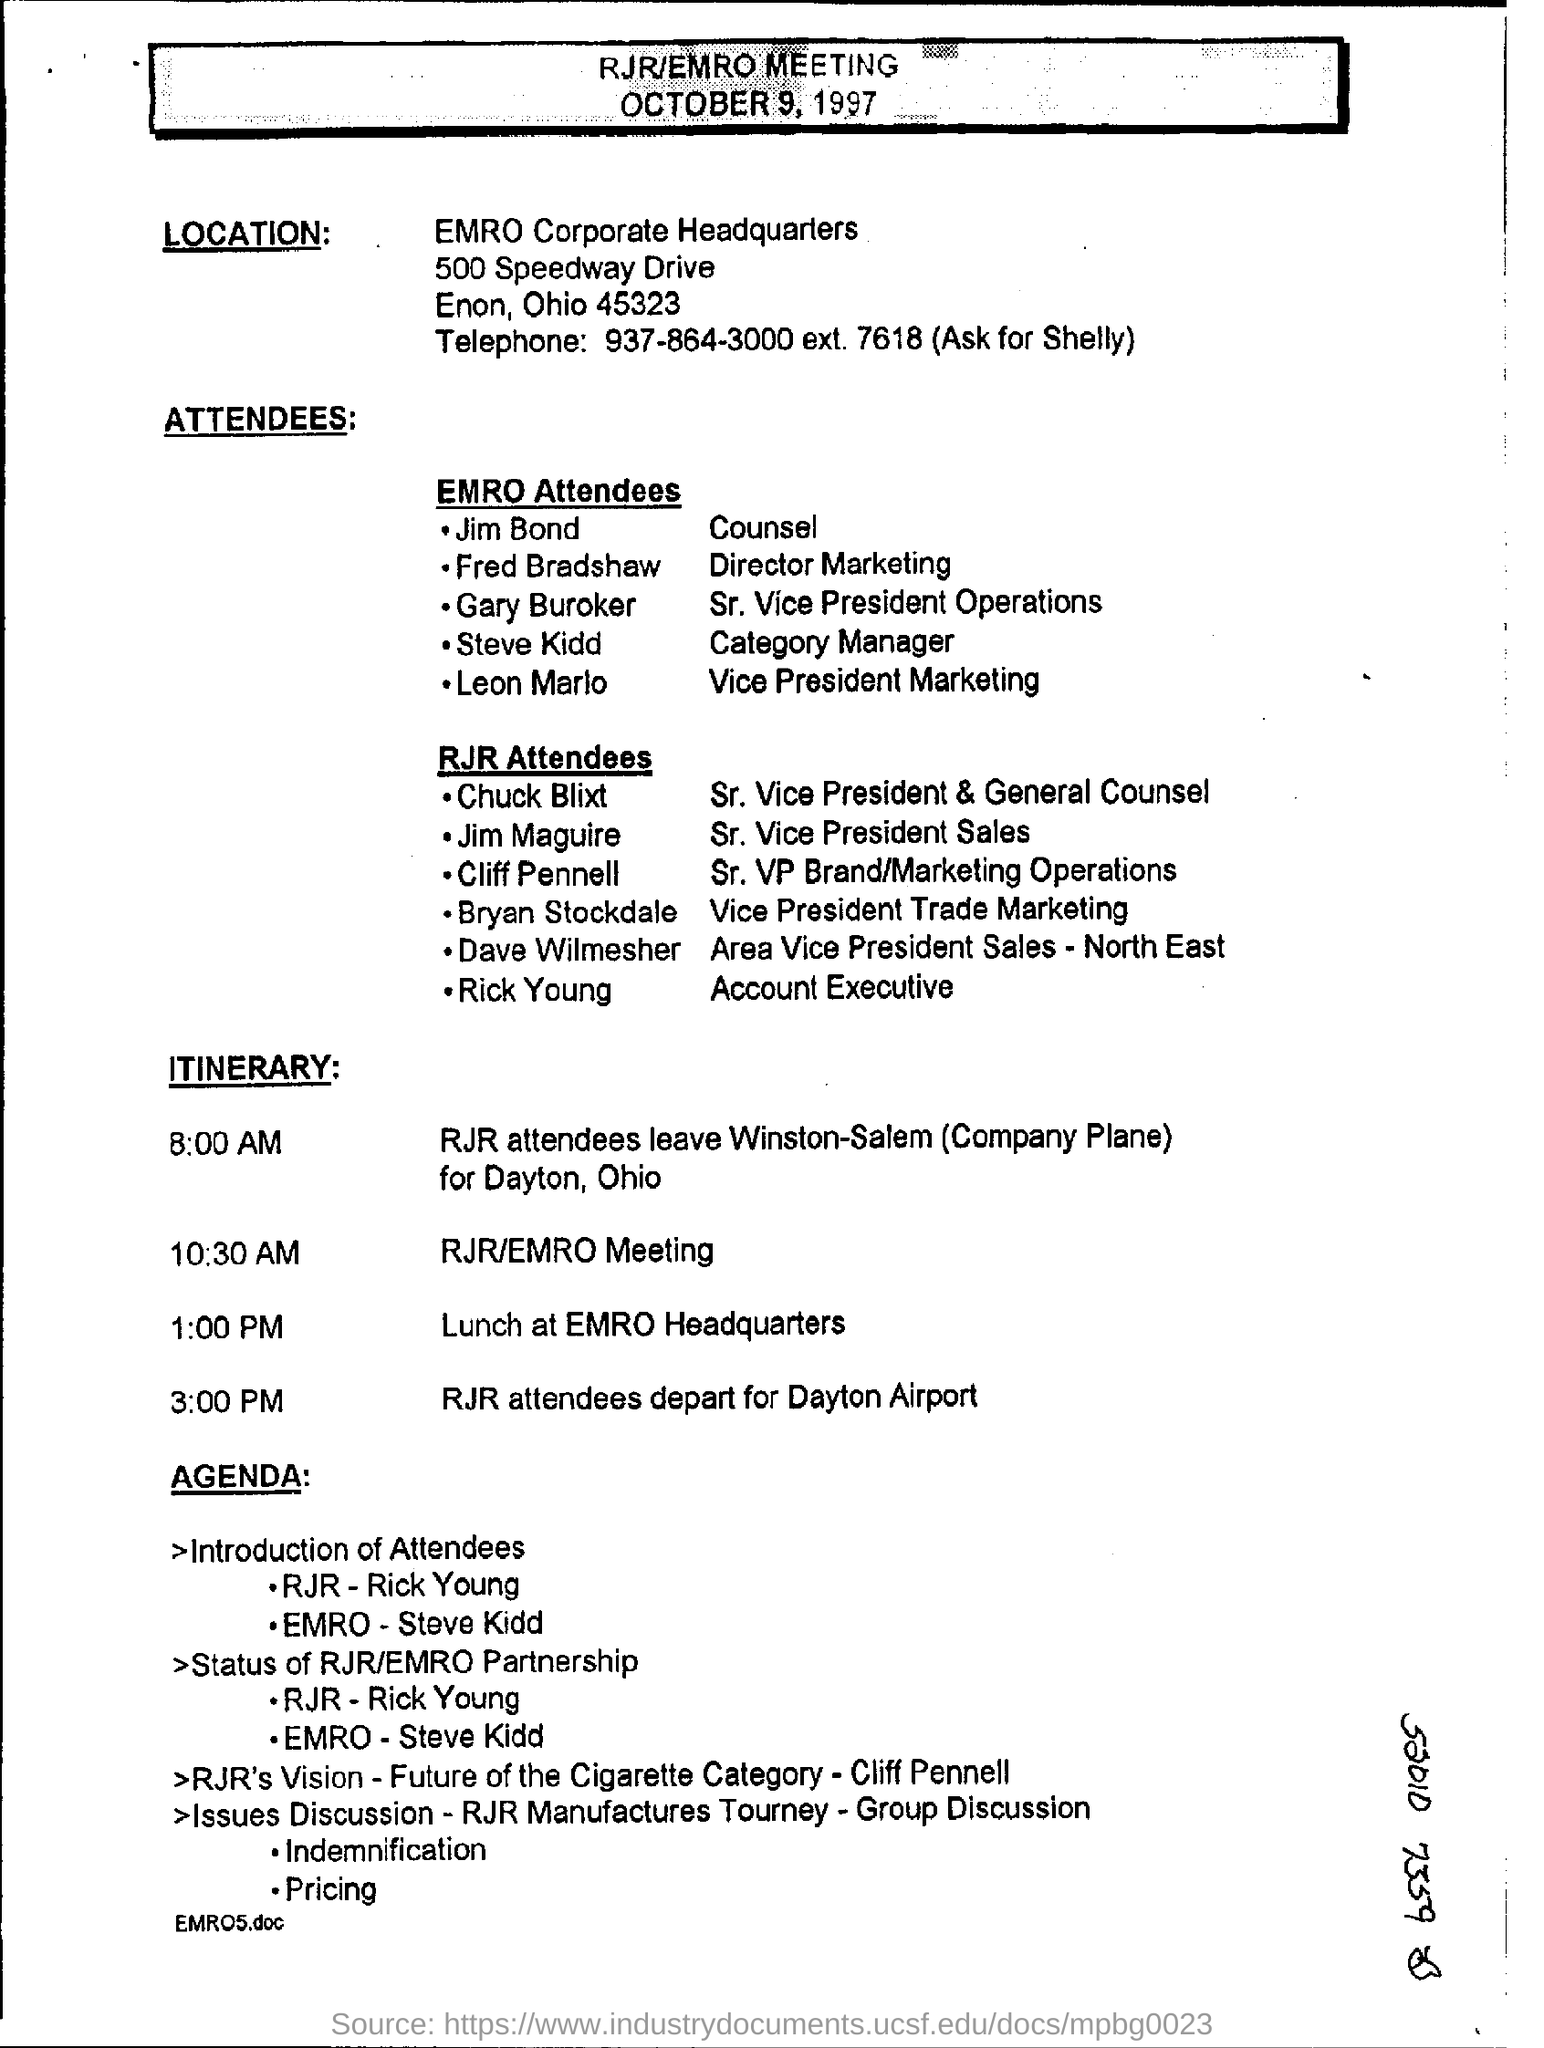What is the time of rjr/emro meeting?
Your answer should be very brief. 10:30  am. 